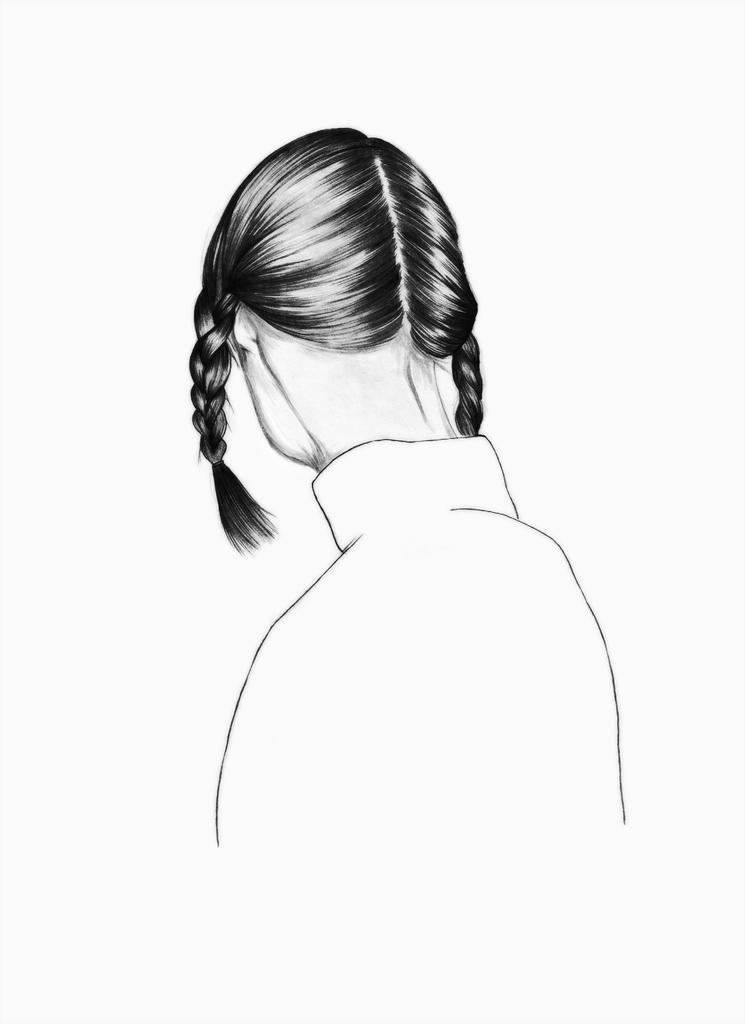What is depicted in the image? There is a drawing of a lady in the image. What type of duck is the lady holding in the image? There is no duck present in the image; it only features a drawing of a lady. Who is the lady's friend in the image? The image only shows a drawing of a lady, and there is no indication of any friends or other characters. 